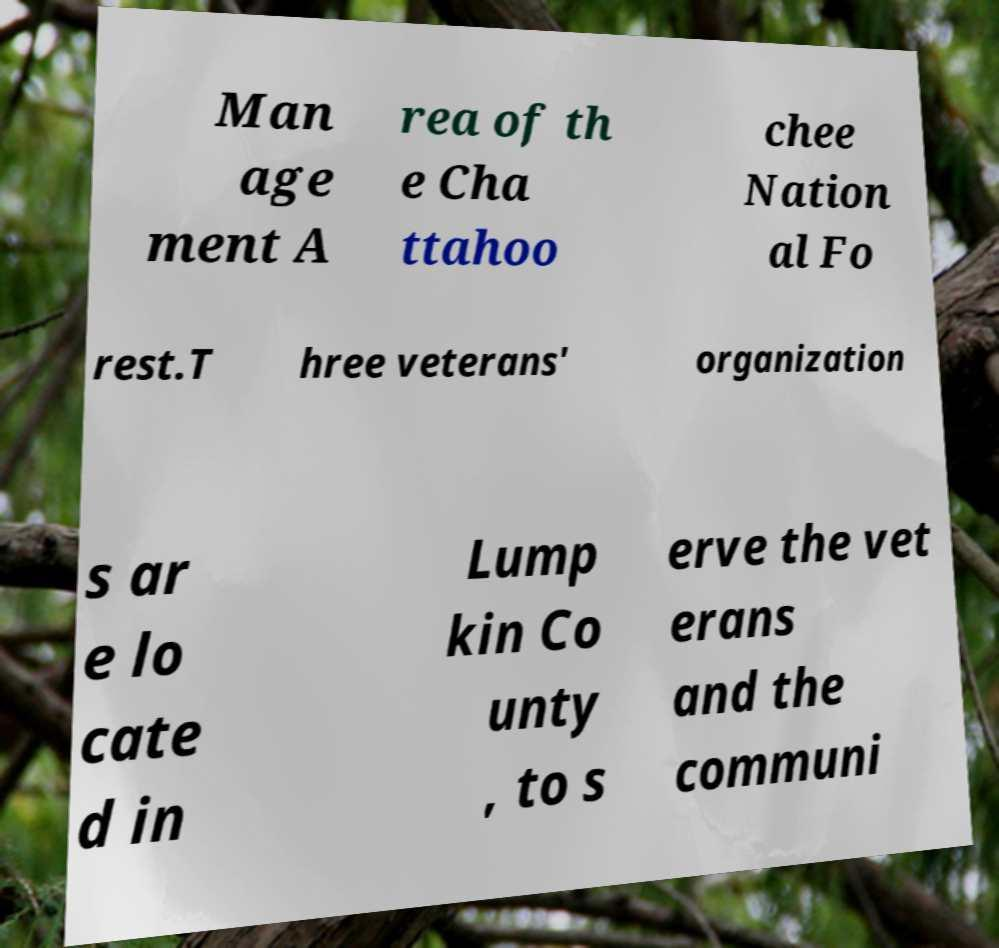There's text embedded in this image that I need extracted. Can you transcribe it verbatim? Man age ment A rea of th e Cha ttahoo chee Nation al Fo rest.T hree veterans' organization s ar e lo cate d in Lump kin Co unty , to s erve the vet erans and the communi 